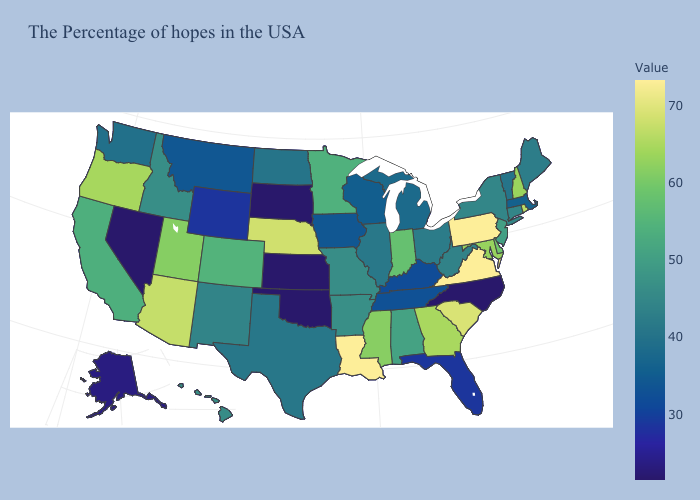Which states have the lowest value in the MidWest?
Keep it brief. Kansas, South Dakota. Does the map have missing data?
Write a very short answer. No. Which states have the highest value in the USA?
Concise answer only. Pennsylvania, Virginia, Louisiana. Among the states that border Wisconsin , does Michigan have the highest value?
Concise answer only. No. 